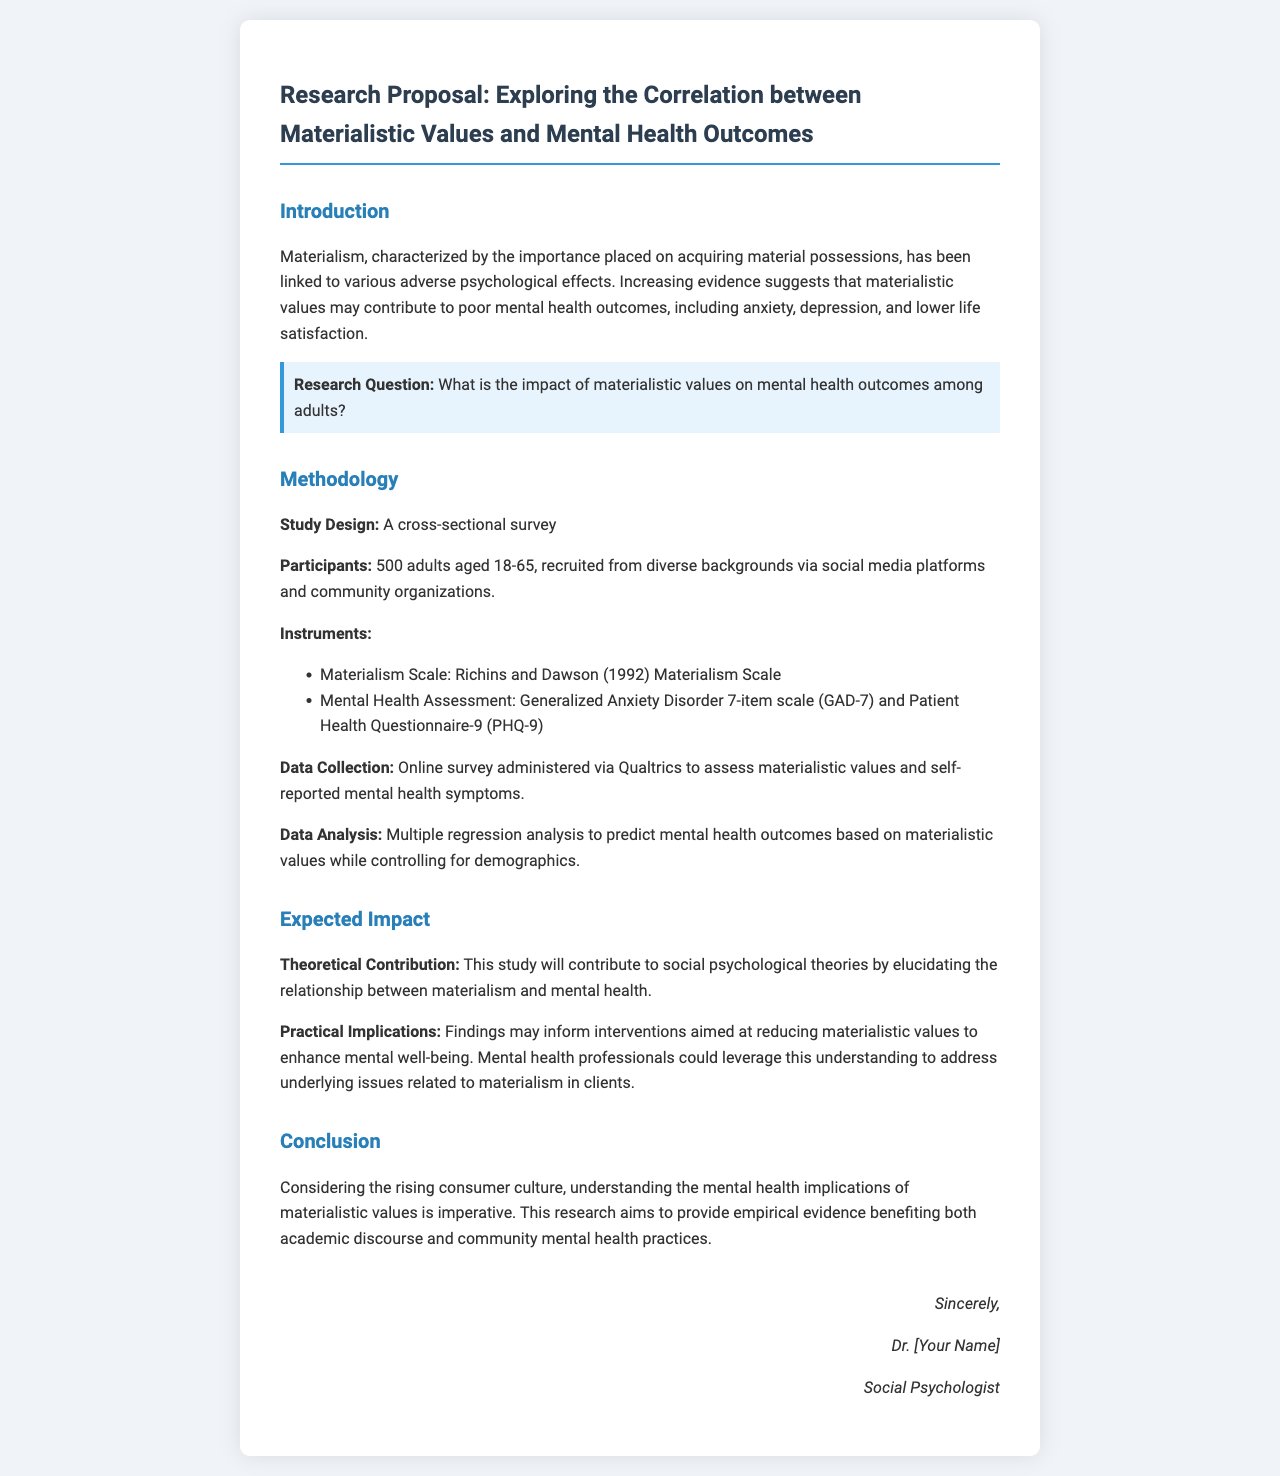What is the main focus of the research proposal? The research proposal focuses on the correlation between materialistic values and mental health outcomes.
Answer: correlation between materialistic values and mental health outcomes How many adults will participate in the study? The document specifies the number of participants recruited for the study.
Answer: 500 adults What age range do the participants belong to? The age range of participants is indicated in the methodology section.
Answer: 18-65 Which scale is used to measure materialism? The specific scale used to measure materialism is mentioned in the instruments section.
Answer: Richins and Dawson (1992) Materialism Scale What mental health assessments will be used in the study? The document lists the assessments used for measuring mental health symptoms.
Answer: GAD-7 and PHQ-9 What is the expected theoretical contribution of the study? The expected contribution of the study to social psychological theories is described in the expected impact section.
Answer: elucidating the relationship between materialism and mental health What method of data collection is employed in the study? The document describes how data will be collected for the research.
Answer: Online survey via Qualtrics What analysis method will be used to interpret the data? The method used for data analysis is specified in the methodology section.
Answer: Multiple regression analysis 